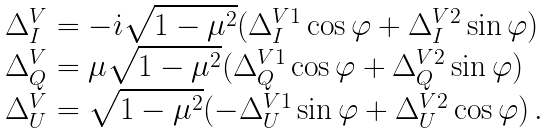<formula> <loc_0><loc_0><loc_500><loc_500>\begin{array} { l } \Delta ^ { V } _ { I } = - \dot { \imath } \sqrt { 1 - \mu ^ { 2 } } ( \Delta _ { I } ^ { V 1 } \cos { \varphi } + \Delta _ { I } ^ { V 2 } \sin { \varphi } ) \\ \Delta _ { Q } ^ { V } = \mu \sqrt { 1 - \mu ^ { 2 } } ( \Delta _ { Q } ^ { V 1 } \cos { \varphi } + \Delta _ { Q } ^ { V 2 } \sin { \varphi } ) \\ \Delta _ { U } ^ { V } = \sqrt { 1 - \mu ^ { 2 } } ( - \Delta _ { U } ^ { V 1 } \sin { \varphi } + \Delta _ { U } ^ { V 2 } \cos { \varphi } ) \, . \end{array}</formula> 